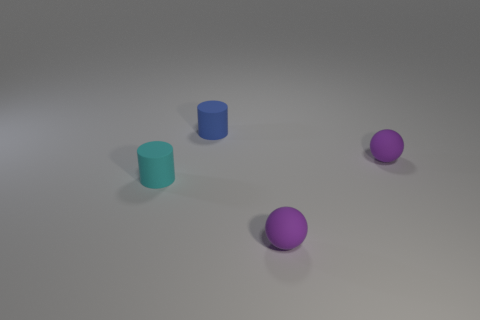The other object that is the same shape as the cyan rubber object is what size?
Keep it short and to the point. Small. What number of rubber things are tiny cylinders or balls?
Offer a terse response. 4. The purple ball that is to the right of the purple rubber sphere in front of the tiny matte thing left of the small blue matte object is made of what material?
Keep it short and to the point. Rubber. There is a rubber object left of the tiny blue rubber object; does it have the same shape as the tiny rubber thing that is in front of the tiny cyan rubber cylinder?
Your answer should be compact. No. There is a matte cylinder in front of the tiny purple rubber ball behind the cyan cylinder; what color is it?
Your answer should be compact. Cyan. How many spheres are tiny cyan things or purple rubber things?
Provide a succinct answer. 2. How many tiny purple balls are behind the purple rubber object in front of the small matte cylinder left of the blue object?
Ensure brevity in your answer.  1. Is there a purple thing that has the same material as the tiny blue thing?
Ensure brevity in your answer.  Yes. Is the material of the blue object the same as the tiny cyan thing?
Provide a succinct answer. Yes. There is a small cylinder to the right of the cyan thing; what number of small blue cylinders are behind it?
Make the answer very short. 0. 